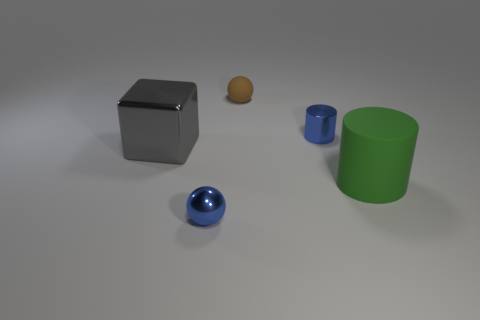How many objects are things left of the metal ball or balls? To the left of the metal ball, there are two objects: a brown clay sphere and a metallic cuboid. 